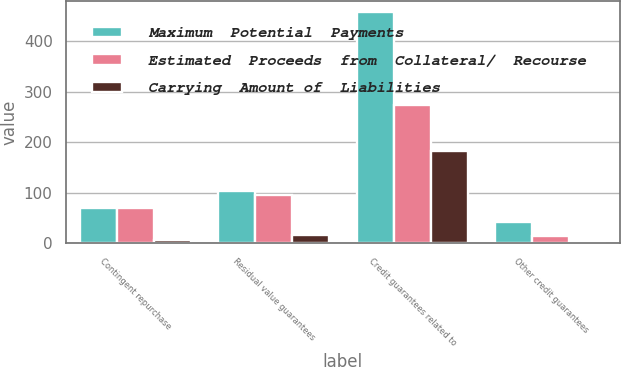Convert chart. <chart><loc_0><loc_0><loc_500><loc_500><stacked_bar_chart><ecel><fcel>Contingent repurchase<fcel>Residual value guarantees<fcel>Credit guarantees related to<fcel>Other credit guarantees<nl><fcel>Maximum  Potential  Payments<fcel>69.5<fcel>103<fcel>457<fcel>43<nl><fcel>Estimated  Proceeds  from  Collateral/  Recourse<fcel>69.5<fcel>96<fcel>274<fcel>14<nl><fcel>Carrying  Amount of  Liabilities<fcel>7<fcel>16<fcel>183<fcel>1<nl></chart> 